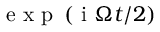<formula> <loc_0><loc_0><loc_500><loc_500>e x p \left ( i \Omega t / 2 \right )</formula> 